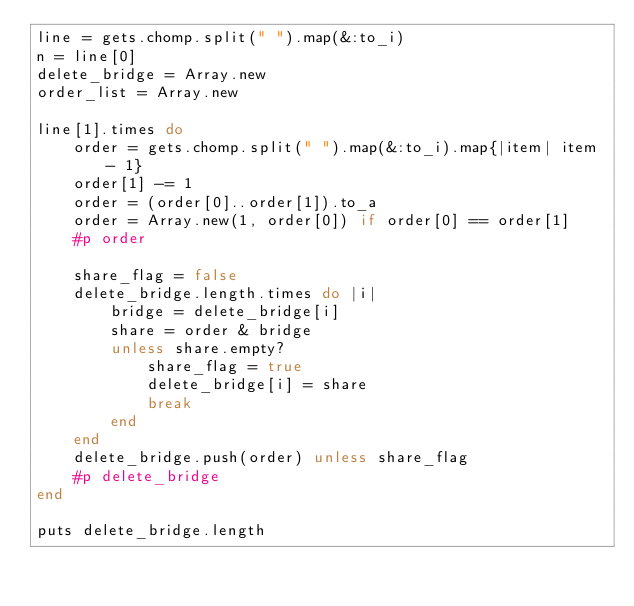Convert code to text. <code><loc_0><loc_0><loc_500><loc_500><_Ruby_>line = gets.chomp.split(" ").map(&:to_i)
n = line[0]
delete_bridge = Array.new
order_list = Array.new

line[1].times do
    order = gets.chomp.split(" ").map(&:to_i).map{|item| item - 1}
    order[1] -= 1
    order = (order[0]..order[1]).to_a
    order = Array.new(1, order[0]) if order[0] == order[1]
    #p order

    share_flag = false
    delete_bridge.length.times do |i|
        bridge = delete_bridge[i]
        share = order & bridge
        unless share.empty?
            share_flag = true
            delete_bridge[i] = share
            break
        end
    end
    delete_bridge.push(order) unless share_flag
    #p delete_bridge
end

puts delete_bridge.length
</code> 